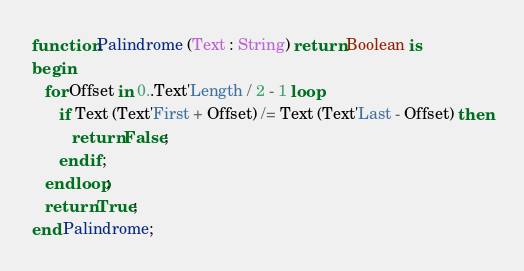<code> <loc_0><loc_0><loc_500><loc_500><_Ada_>function Palindrome (Text : String) return Boolean is
begin
   for Offset in 0..Text'Length / 2 - 1 loop
      if Text (Text'First + Offset) /= Text (Text'Last - Offset) then
         return False;
      end if;
   end loop;
   return True;
end Palindrome;
</code> 